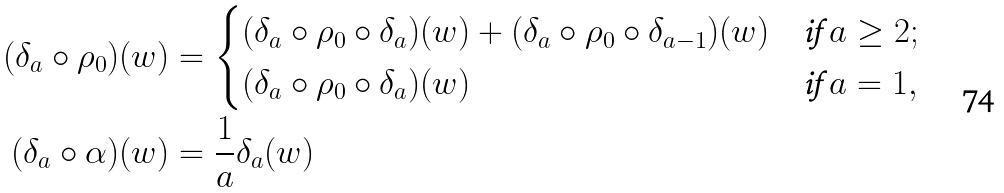<formula> <loc_0><loc_0><loc_500><loc_500>( \delta _ { a } \circ \rho _ { 0 } ) ( w ) & = \begin{cases} ( \delta _ { a } \circ \rho _ { 0 } \circ \delta _ { a } ) ( w ) + ( \delta _ { a } \circ \rho _ { 0 } \circ \delta _ { a - 1 } ) ( w ) & \text {if $a\geq2$} ; \\ ( \delta _ { a } \circ \rho _ { 0 } \circ \delta _ { a } ) ( w ) & \text {if $a=1$} , \end{cases} \\ ( \delta _ { a } \circ \alpha ) ( w ) & = \frac { 1 } { a } \delta _ { a } ( w )</formula> 